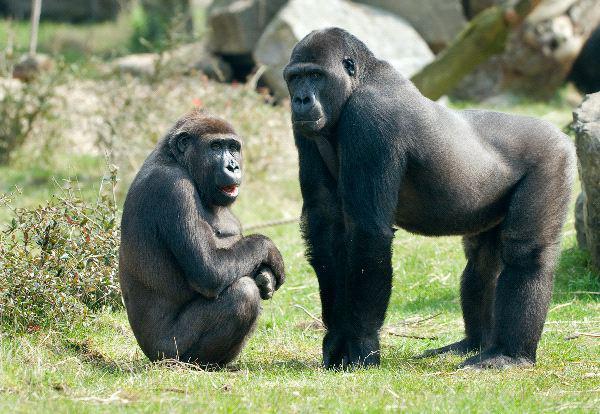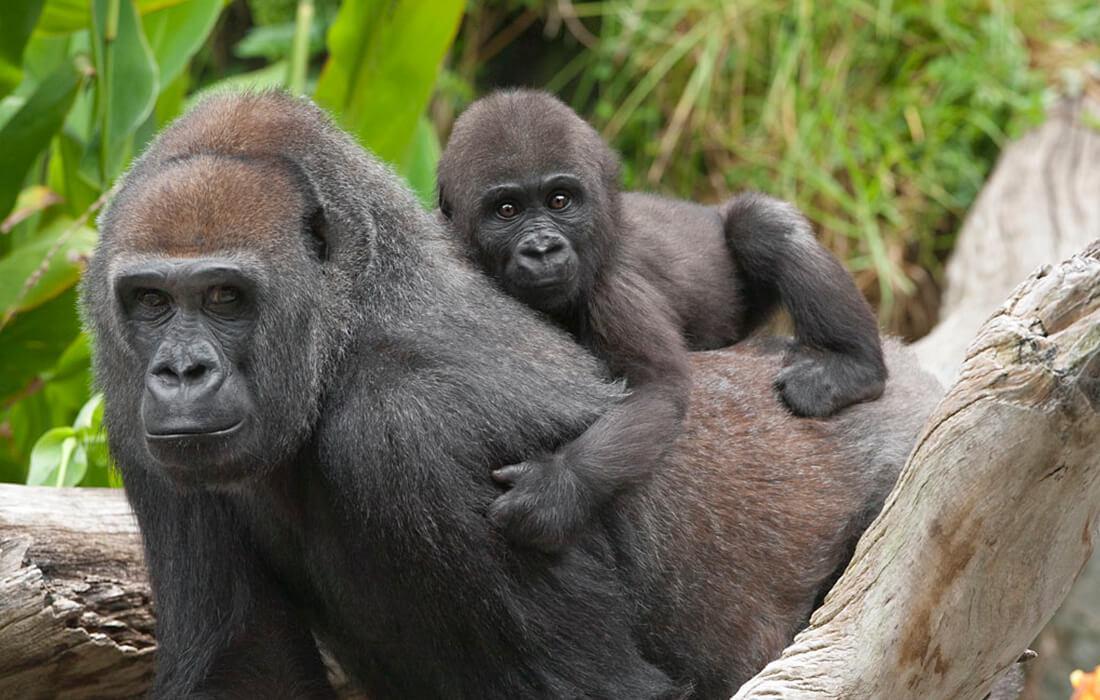The first image is the image on the left, the second image is the image on the right. Assess this claim about the two images: "There is a single ape holding something in the left image". Correct or not? Answer yes or no. No. The first image is the image on the left, the second image is the image on the right. Given the left and right images, does the statement "An image shows exactly one ape, sitting and holding something in its hand." hold true? Answer yes or no. No. 